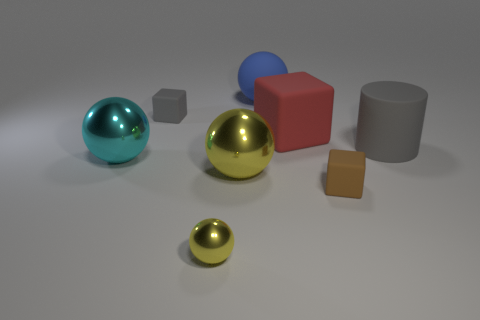Add 1 big purple blocks. How many objects exist? 9 Subtract all cylinders. How many objects are left? 7 Add 1 large red rubber blocks. How many large red rubber blocks are left? 2 Add 2 large red blocks. How many large red blocks exist? 3 Subtract 0 purple spheres. How many objects are left? 8 Subtract all large shiny objects. Subtract all big cubes. How many objects are left? 5 